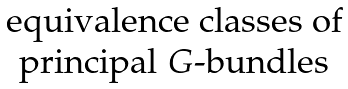<formula> <loc_0><loc_0><loc_500><loc_500>\begin{matrix} \text {equivalence classes of} \\ \text {principal $G$-bundles} \end{matrix}</formula> 